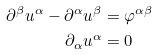<formula> <loc_0><loc_0><loc_500><loc_500>\partial ^ { \beta } u ^ { \alpha } - \partial ^ { \alpha } u ^ { \beta } & = \varphi ^ { \alpha \beta } \\ \partial _ { \alpha } u ^ { \alpha } & = 0</formula> 